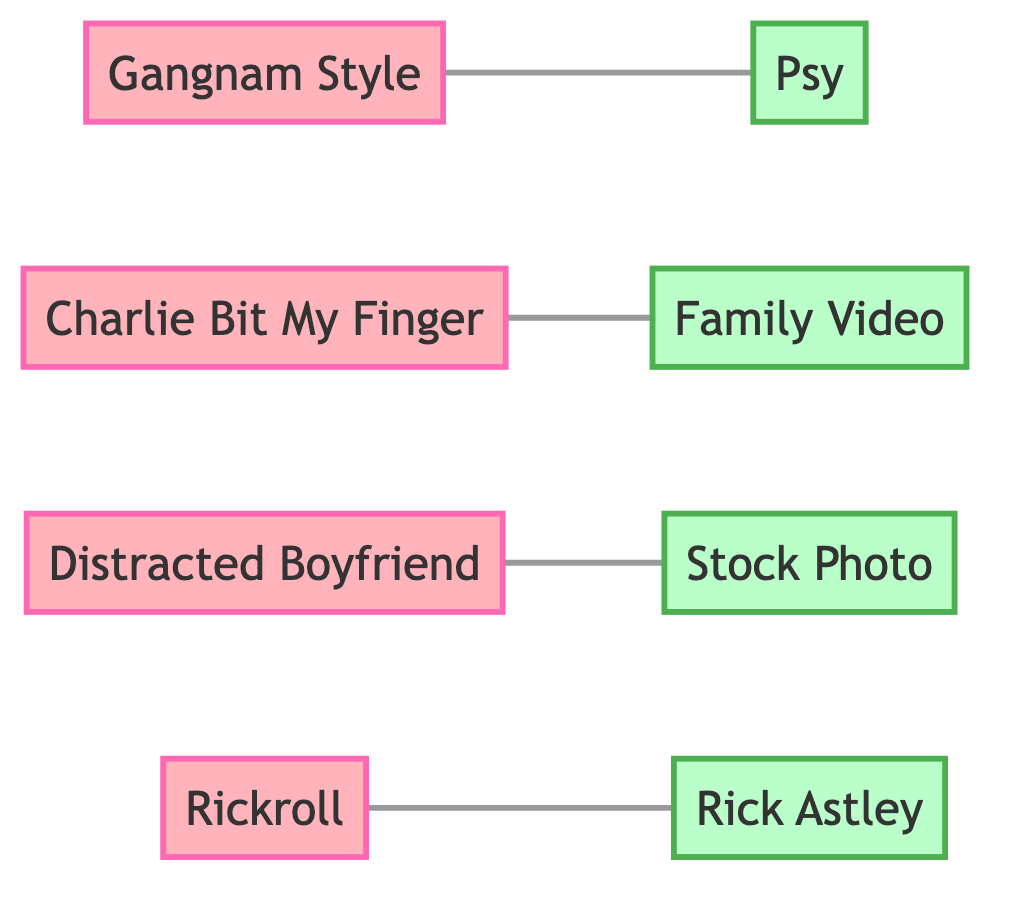What is the total number of nodes in the diagram? The diagram includes a list of nodes, each representing either a meme or a source. By counting, there are a total of 8 nodes: 4 memes and 4 sources.
Answer: 8 Which meme is connected to the source "Psy"? By examining the edges in the diagram, the meme "Gangnam Style" has a direct connection to the source "Psy."
Answer: Gangnam Style How many memes are represented in the diagram? The diagram clearly specifies that there are 4 nodes classified as memes: "Gangnam Style," "Charlie Bit My Finger," "Distracted Boyfriend," and "Rickroll."
Answer: 4 What type of node is "Rickroll"? By determining the classification of "Rickroll" in the diagram, it is evident that this node is categorized as a meme.
Answer: Meme Which source is linked with the meme "Distracted Boyfriend"? Analyzing the edges shows that the source "Stock Photo" is connected to the meme "Distracted Boyfriend."
Answer: Stock Photo List all the sources mentioned in the diagram. By reviewing the nodes designated as sources, they include "Psy," "Family Video," "Stock Photo," and "Rick Astley."
Answer: Psy, Family Video, Stock Photo, Rick Astley How many edges are in the diagram? The edges represent the connections between nodes, and a review reveals there are 4 edges connecting the 4 memes to their respective sources.
Answer: 4 Who is the source of the meme "Rickroll"? The edge leads directly from the meme "Rickroll" to its source, which is identified as "Rick Astley."
Answer: Rick Astley Which meme does "Family Video" connect to in the diagram? The edge shows a direct connection from the source "Family Video" to the meme "Charlie Bit My Finger."
Answer: Charlie Bit My Finger 